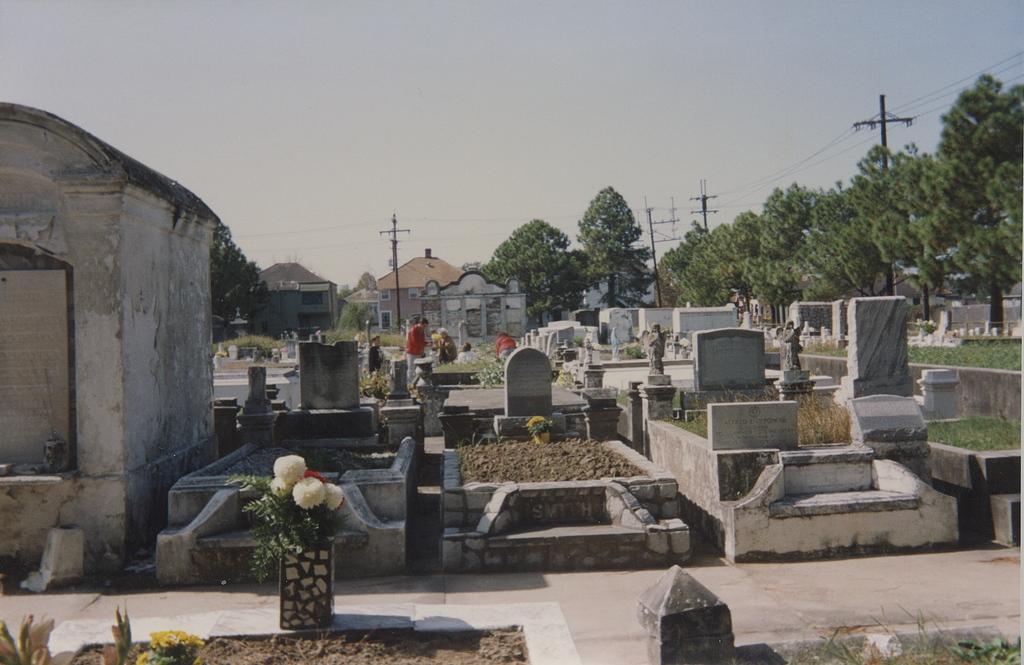Please provide a concise description of this image. In this picture we can see few graves and few people, in the background we can find few houses, trees and poles. 